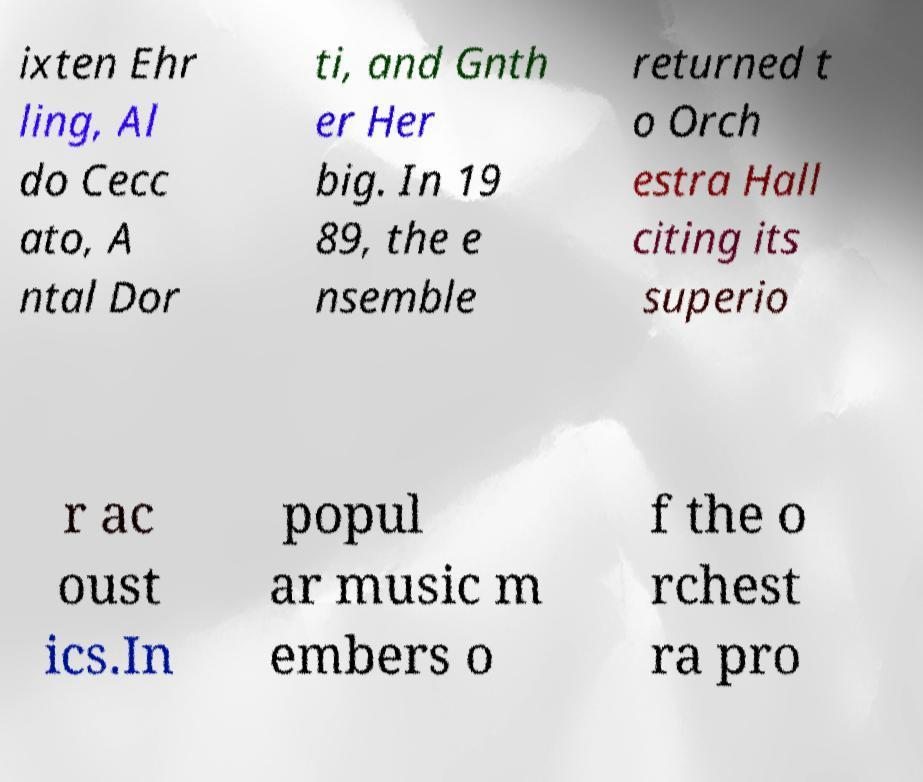What messages or text are displayed in this image? I need them in a readable, typed format. ixten Ehr ling, Al do Cecc ato, A ntal Dor ti, and Gnth er Her big. In 19 89, the e nsemble returned t o Orch estra Hall citing its superio r ac oust ics.In popul ar music m embers o f the o rchest ra pro 